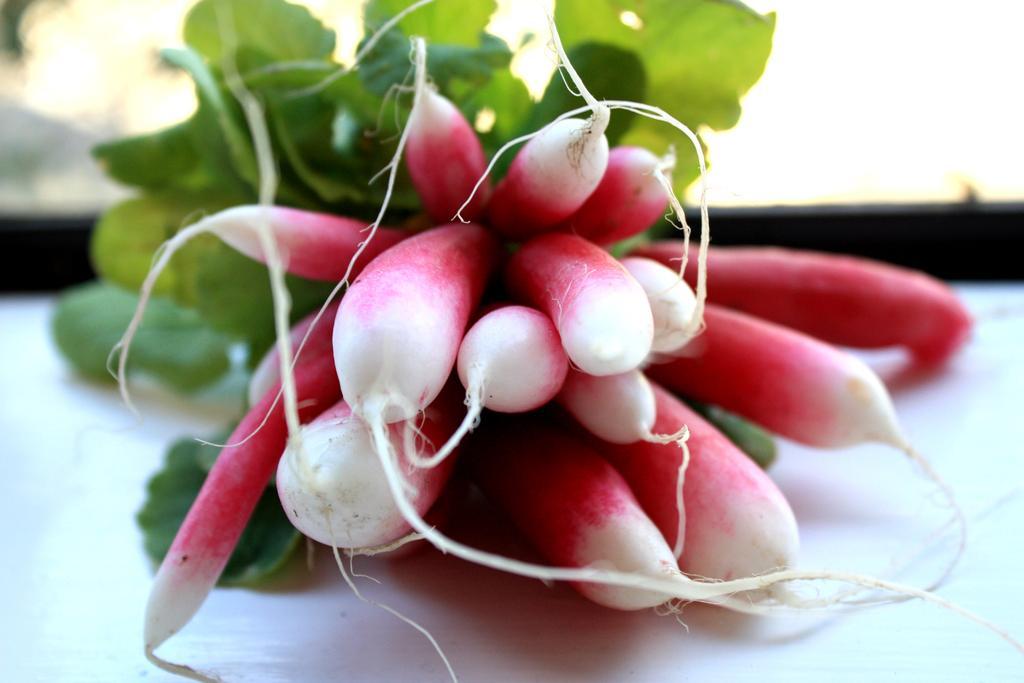Could you give a brief overview of what you see in this image? In this picture we can see radishes and green leaves on a white surface. Background is blurry. 